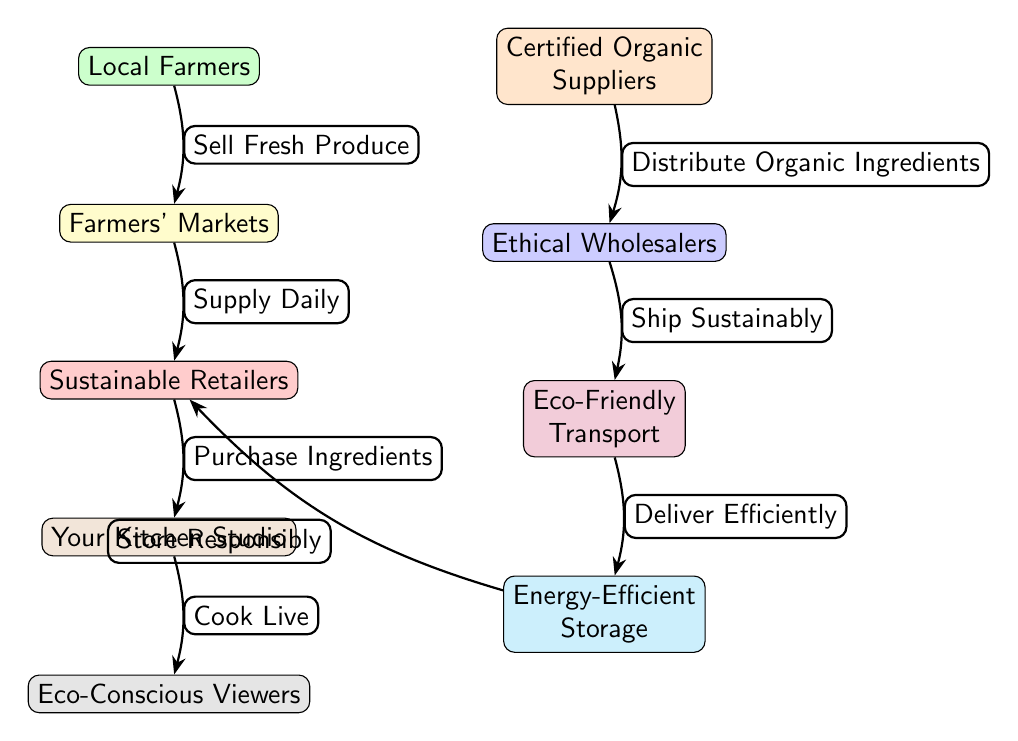What's the node above "Your Kitchen Studio"? The node directly above "Your Kitchen Studio" is "Sustainable Retailers". By looking at the vertical arrangement of nodes in the diagram, we can trace upwards from "Your Kitchen Studio" to find the immediately preceding node.
Answer: Sustainable Retailers How many main nodes are in this diagram? By counting each distinct labeled node in the diagram, we find there are a total of 8 nodes that represent various entities in the food chain. This includes Local Farmers, Certified Organic Suppliers, Farmers' Markets, Ethical Wholesalers, Eco-Friendly Transport, Energy-Efficient Storage, Sustainable Retailers, Your Kitchen Studio, and Eco-Conscious Viewers.
Answer: 8 What is the relationship between "Ethical Wholesalers" and "Eco-Friendly Transport"? The diagram indicates that Ethical Wholesalers directly ship their products sustainably to Eco-Friendly Transport. This is shown with an edge labeled "Ship Sustainably" connecting these two nodes.
Answer: Ship Sustainably Which node is directly supplied by "Local Farmers"? "Farmers' Markets" is directly supplied by "Local Farmers". This was indicated by the arrow pointing from Local Farmers to Farmers' Markets, with the label "Sell Fresh Produce."
Answer: Farmers' Markets What connects "Sustainable Retailers" to "Your Kitchen Studio"? The connection is formed by the edge labeled "Purchase Ingredients." This indicates that Sustainable Retailers supply the ingredients directly to Your Kitchen Studio for cooking.
Answer: Purchase Ingredients Which node is the final recipient of the flow in this food chain? The final recipient is "Eco-Conscious Viewers." This is noted by the flow moving from "Your Kitchen Studio" to "Eco-Conscious Viewers," indicating that cooking events are presented to them.
Answer: Eco-Conscious Viewers What does "Eco-Friendly Transport" deliver to? "Eco-Friendly Transport" delivers to "Energy-Efficient Storage". The edge linking these two nodes is labeled "Deliver Efficiently," showing that the transport process is directed to the storage phase.
Answer: Energy-Efficient Storage Who distributes organic ingredients within this food chain? "Certified Organic Suppliers" are responsible for distributing organic ingredients. This is indicated by the edge labeled "Distribute Organic Ingredients" leading to Ethical Wholesalers.
Answer: Certified Organic Suppliers What practices ensure ingredients are sold fresh at local markets? The practice ensuring freshness is the action labeled "Sell Fresh Produce" from Local Farmers to Farmers' Markets. The diagram clearly shows this relationship as crucial for a vibrant food supply.
Answer: Sell Fresh Produce 